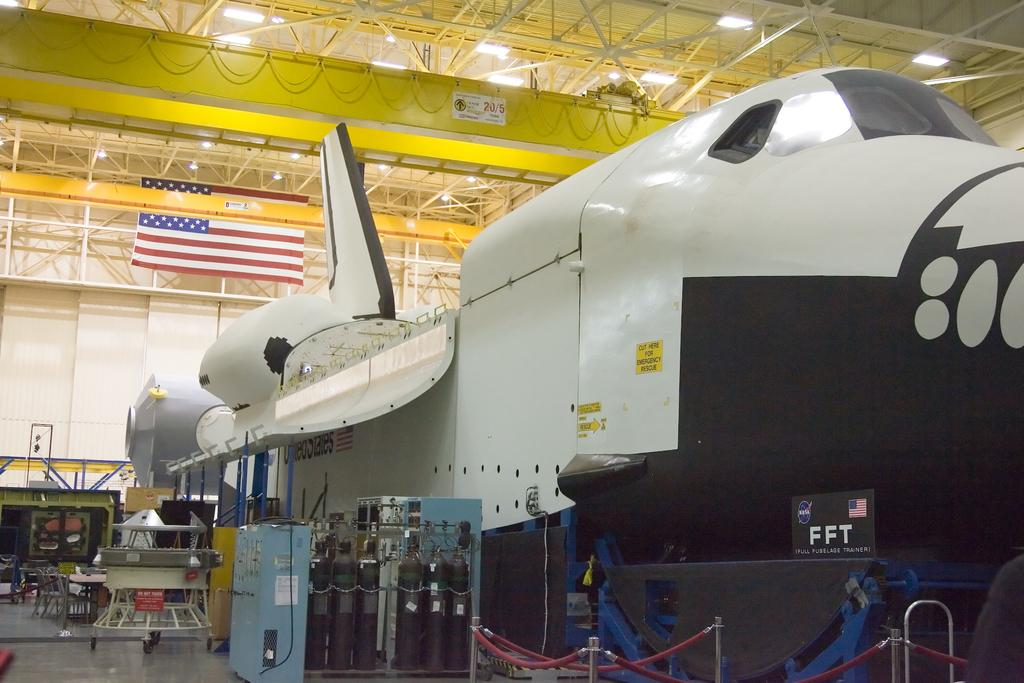<image>
Offer a succinct explanation of the picture presented. A space shuttle is in its hanger and has FFT, Full Fuselage Trainer. on its front end. 